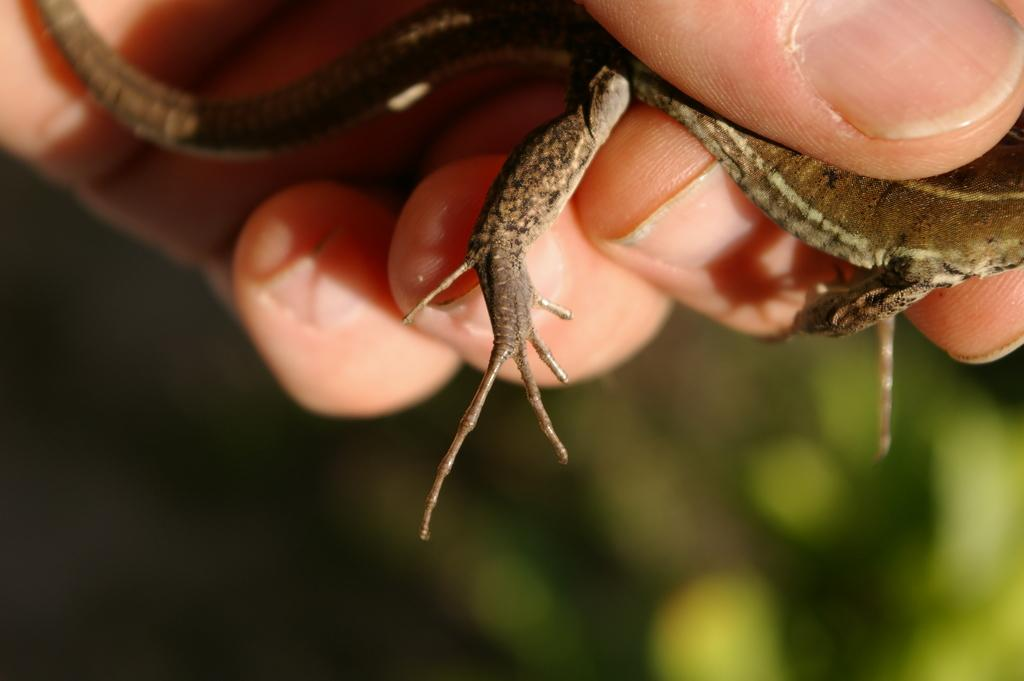What type of animal is in the foreground of the image? There is a reptile in the foreground of the image. How is the reptile being held in the image? The reptile is being held in a hand. Can you describe the background of the image? The background of the image is blurred. What type of reward is the reptile receiving in the image? There is no reward present in the image; the reptile is simply being held in a hand. Can you see any bats flying in the background of the image? There are no bats visible in the image; the background is blurred, and only the reptile and the hand holding it are in focus. 